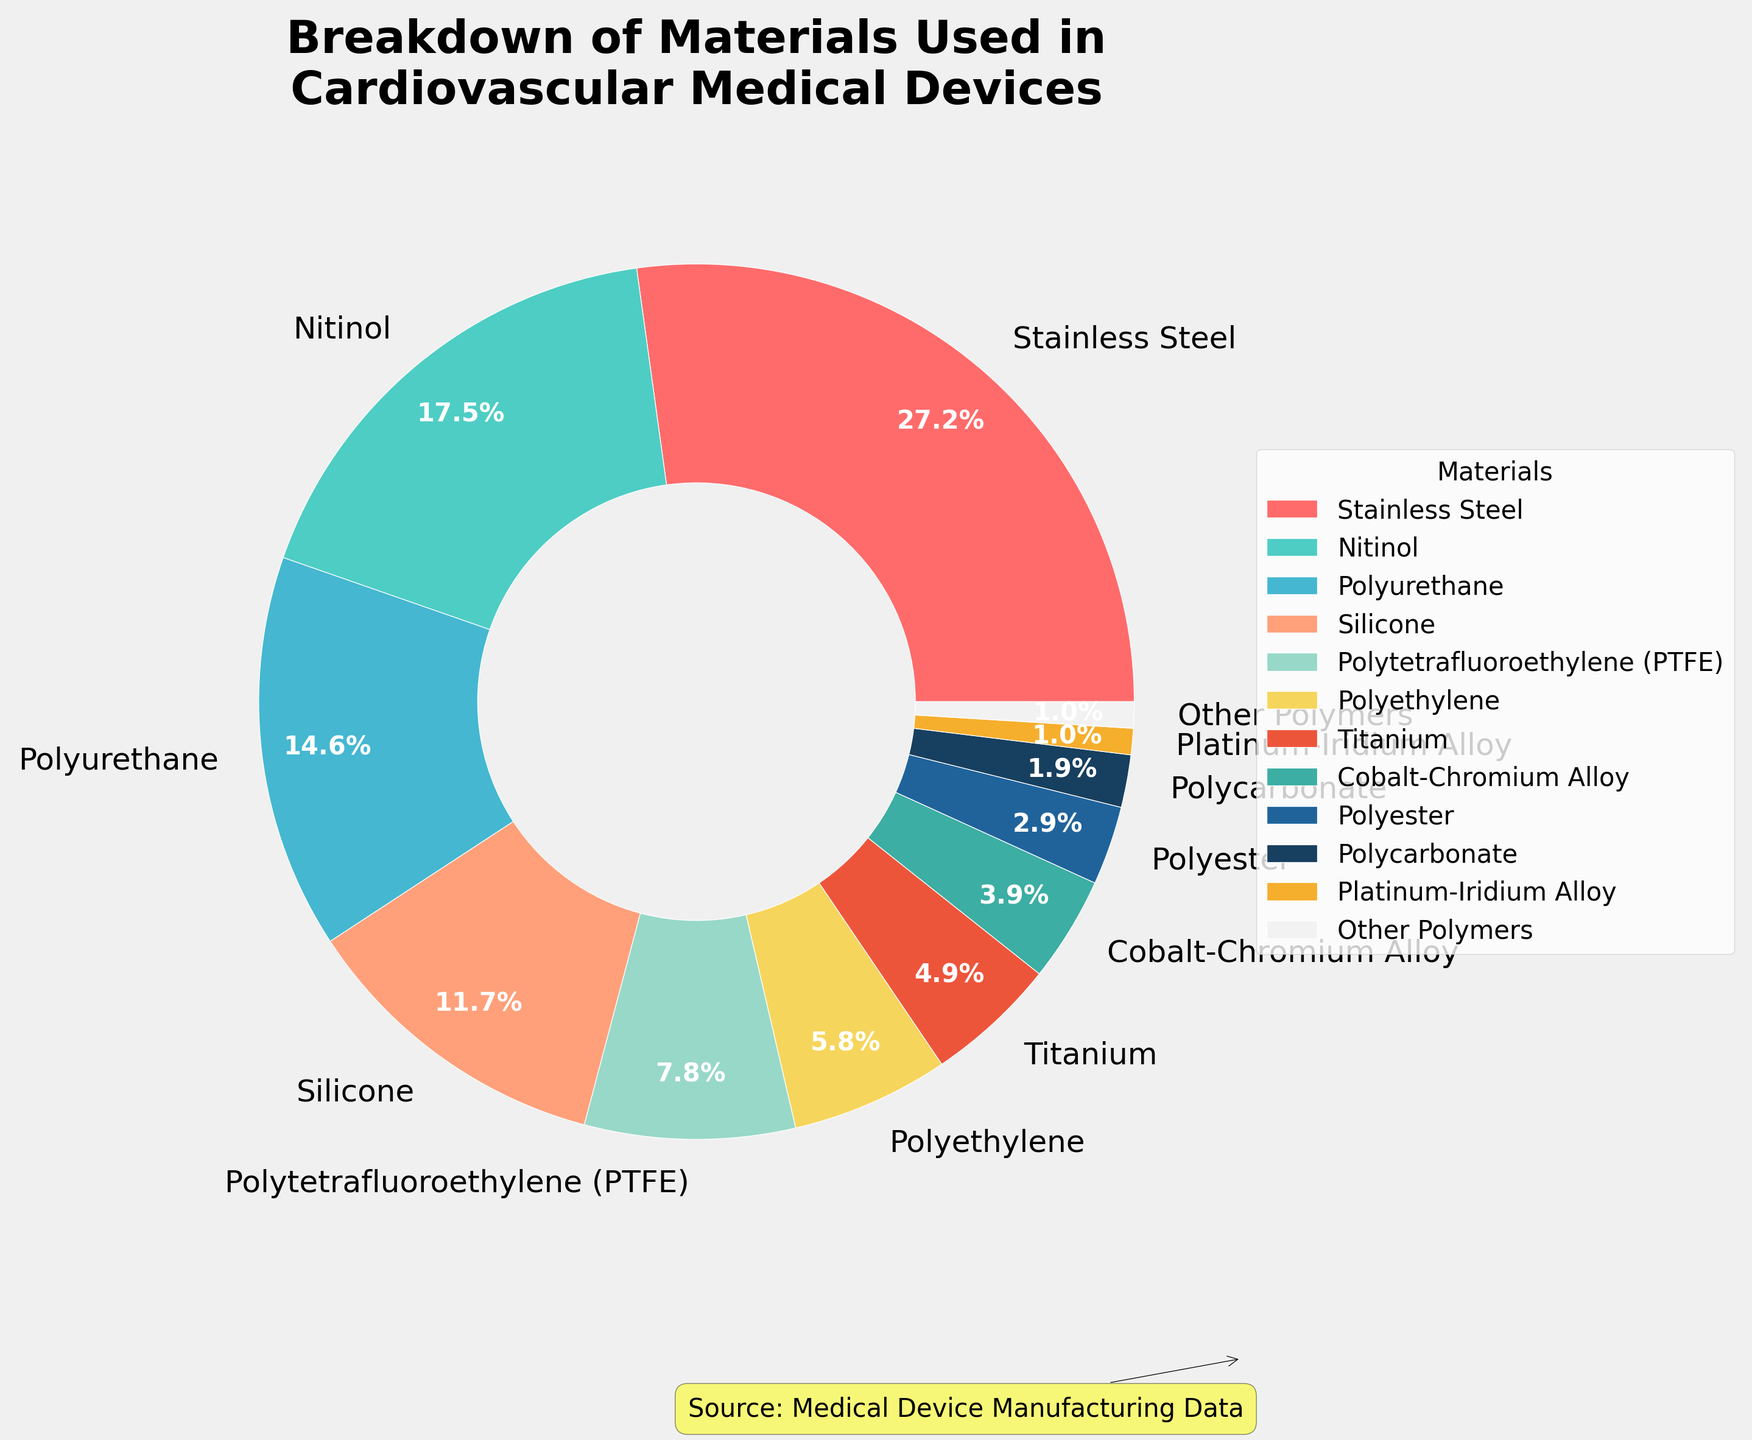What is the most used material in manufacturing cardiovascular medical devices? The pie chart shows that Stainless Steel has the largest percentage section, which is 28%, indicating it is the most used material.
Answer: Stainless Steel What percentage of materials used in manufacturing cardiovascular devices are metals? Summing up the percentages of Stainless Steel (28%), Nitinol (18%), Titanium (5%), Cobalt-Chromium Alloy (4%), and Platinum-Iridium Alloy (1%), we get 28 + 18 + 5 + 4 + 1 = 56%.
Answer: 56% Which material is used more, Polyurethane or Silicone? By comparing their sections in the pie chart, Polyurethane has 15% and Silicone has 12%. Therefore, Polyurethane is used more.
Answer: Polyurethane How much more percentage does Stainless Steel have compared to Polyethylene? Stainless Steel has a 28% share, whereas Polyethylene has a 6% share. The difference is 28% - 6% = 22%.
Answer: 22% What is the combined percentage of all polymer materials used in cardiovascular medical devices? Adding the percentages of Polyurethane (15%), Silicone (12%), Polytetrafluoroethylene (PTFE) (8%), Polyethylene (6%), Polyester (3%), Polycarbonate (2%), and Other Polymers (1%), we get 15 + 12 + 8 + 6 + 3 + 2 + 1 = 47%.
Answer: 47% Are there more materials used that have a percentage greater than or equal to 10% or less than 10%? Materials with percentages greater than or equal to 10% are Stainless Steel (28%), Nitinol (18%), Polyurethane (15%), and Silicone (12%), which totals to 4 materials. Materials with percentages less than 10% are Polytetrafluoroethylene (PTFE) (8%), Polyethylene (6%), Titanium (5%), Cobalt-Chromium Alloy (4%), Polyester (3%), Polycarbonate (2%), Platinum-Iridium Alloy (1%), and Other Polymers (1%), which totals to 8 materials. Therefore, there are more materials with percentages less than 10%.
Answer: Less than 10% Which material has the smallest usage percentage? The pie chart indicates that Platinum-Iridium Alloy and Other Polymers each have a share of 1%, which is the smallest percentage.
Answer: Platinum-Iridium Alloy, Other Polymers What percentage of total usage do Nitinol and Polytetrafluoroethylene (PTFE) have combined? Adding the percentages of Nitinol (18%) and Polytetrafluoroethylene (PTFE) (8%), we get 18 + 8 = 26%.
Answer: 26% What color represents Titanium in the pie chart? Based on the color scheme used in the pie chart and the legend provided, Titanium is represented by a central dark gray color.
Answer: Central dark gray 